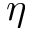Convert formula to latex. <formula><loc_0><loc_0><loc_500><loc_500>\eta</formula> 